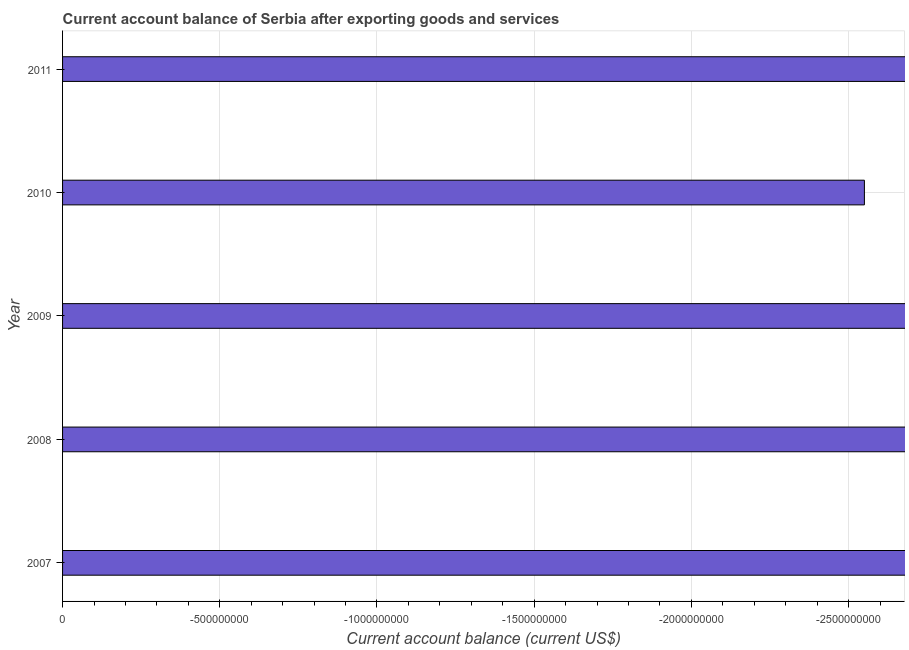What is the title of the graph?
Offer a very short reply. Current account balance of Serbia after exporting goods and services. What is the label or title of the X-axis?
Provide a succinct answer. Current account balance (current US$). What is the current account balance in 2011?
Your answer should be compact. 0. Across all years, what is the minimum current account balance?
Give a very brief answer. 0. What is the median current account balance?
Provide a short and direct response. 0. In how many years, is the current account balance greater than -2500000000 US$?
Provide a succinct answer. 0. In how many years, is the current account balance greater than the average current account balance taken over all years?
Offer a terse response. 0. How many bars are there?
Make the answer very short. 0. What is the difference between two consecutive major ticks on the X-axis?
Ensure brevity in your answer.  5.00e+08. What is the Current account balance (current US$) in 2007?
Make the answer very short. 0. What is the Current account balance (current US$) in 2008?
Your answer should be compact. 0. What is the Current account balance (current US$) of 2009?
Your response must be concise. 0. What is the Current account balance (current US$) in 2010?
Make the answer very short. 0. What is the Current account balance (current US$) in 2011?
Make the answer very short. 0. 